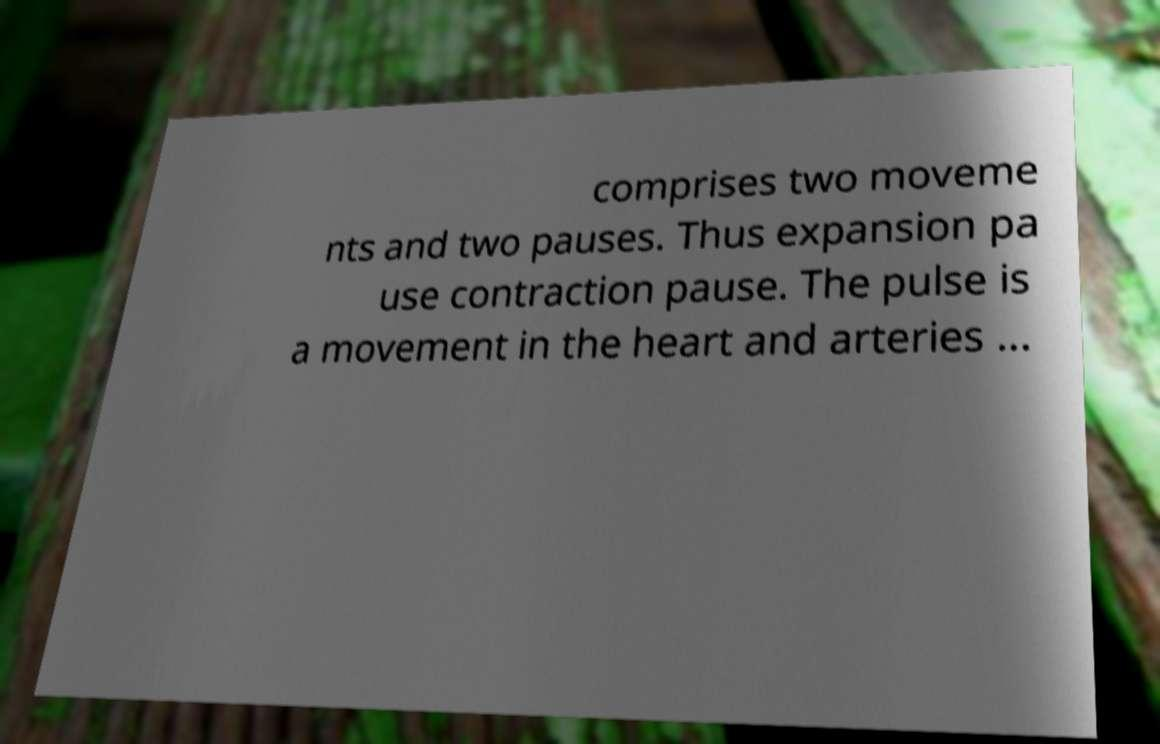There's text embedded in this image that I need extracted. Can you transcribe it verbatim? comprises two moveme nts and two pauses. Thus expansion pa use contraction pause. The pulse is a movement in the heart and arteries ... 